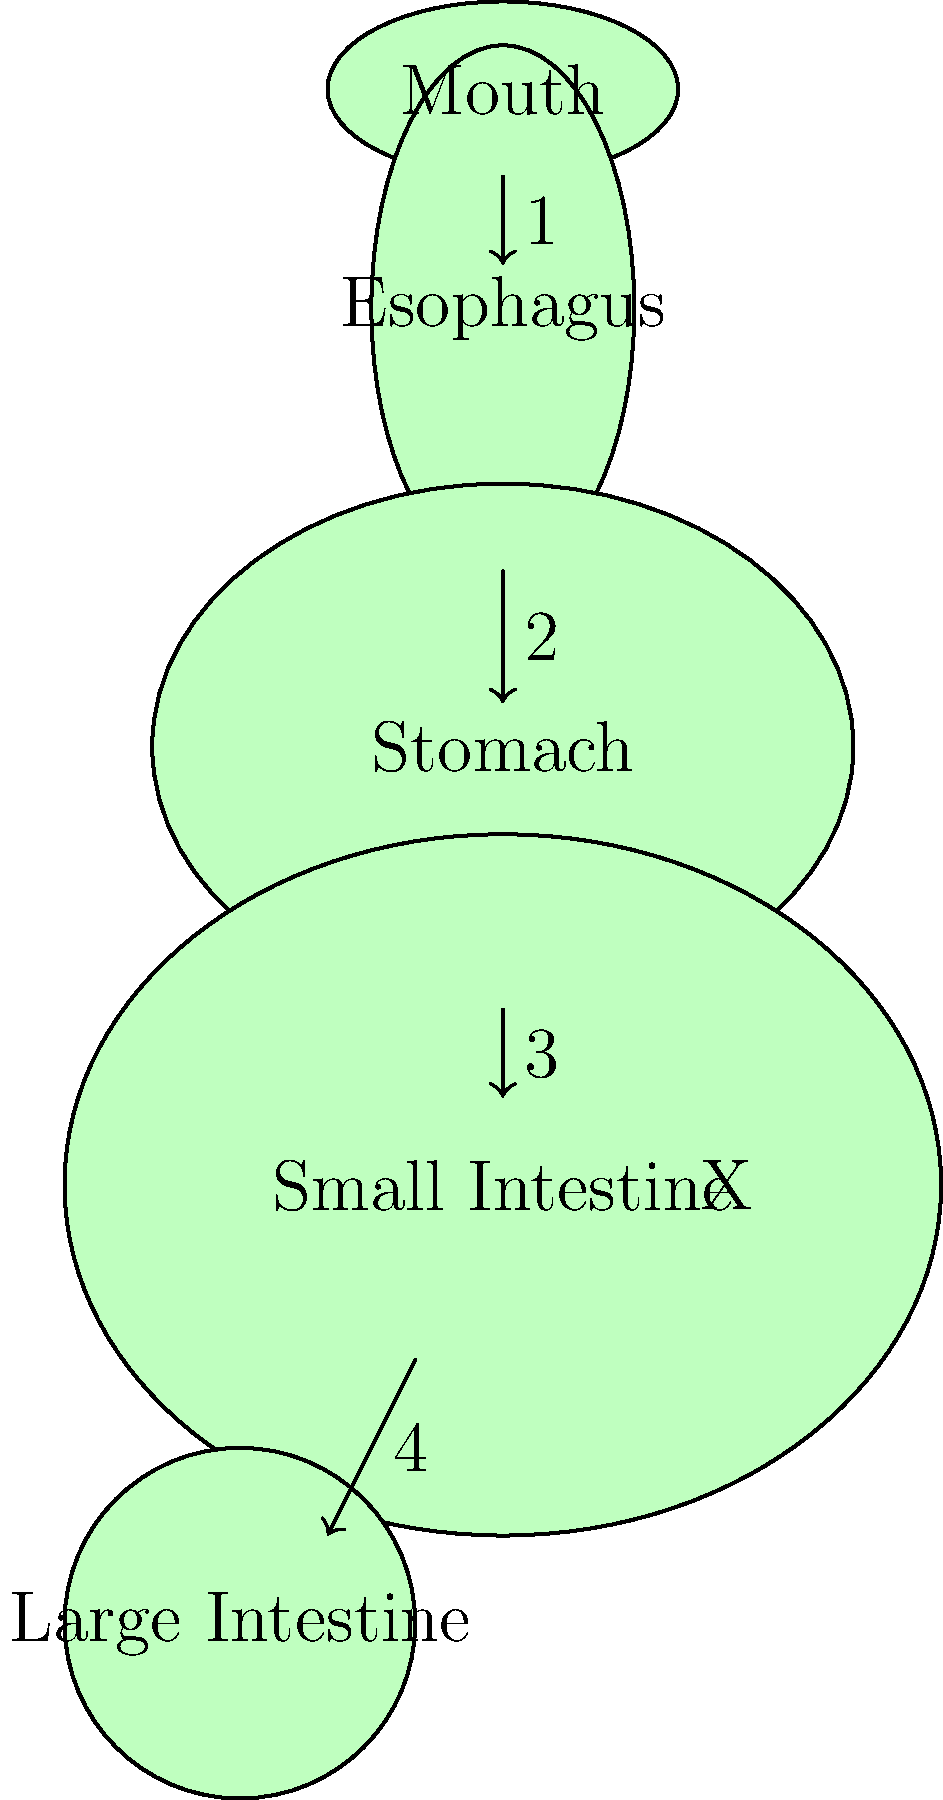In the diagram of the digestive system, which numbered stage is most likely to be affected by a rare genetic disorder that impairs nutrient absorption? What specific part of the digestive system does this correspond to, and why is it crucial for nutrient absorption? To answer this question, let's analyze each stage of the digestive system:

1. Stage 1: This represents the passage from the mouth to the esophagus. While important for initial food processing, it's not a primary site for nutrient absorption.

2. Stage 2: This shows the movement from the esophagus to the stomach. The stomach mainly breaks down food further but doesn't absorb many nutrients.

3. Stage 3: This indicates the transition from the stomach to the small intestine. This is the key area for our answer.

4. Stage 4: This shows the passage from the small intestine to the large intestine. While some water and electrolytes are absorbed here, it's not the primary site for nutrient absorption.

The small intestine, labeled with an "X" in the diagram, is the most critical site for nutrient absorption. It's at stage 3 where food enters the small intestine from the stomach.

The small intestine is crucial for nutrient absorption because:

1. It has a large surface area due to its length and the presence of villi and microvilli.
2. It contains specialized cells (enterocytes) designed for absorption.
3. Most digestive enzymes are active here, breaking down food into absorbable molecules.
4. It's where most vitamins, minerals, carbohydrates, proteins, and fats are absorbed into the bloodstream.

A rare genetic disorder affecting nutrient absorption would most likely impact the function of the small intestine. This could be due to:

- Mutations affecting the production of digestive enzymes
- Abnormalities in the structure of villi or microvilli
- Defects in specific nutrient transporters in the enterocytes

Therefore, stage 3, corresponding to the small intestine, is the most likely to be affected by a rare genetic disorder impairing nutrient absorption.
Answer: Stage 3 (Small Intestine) 